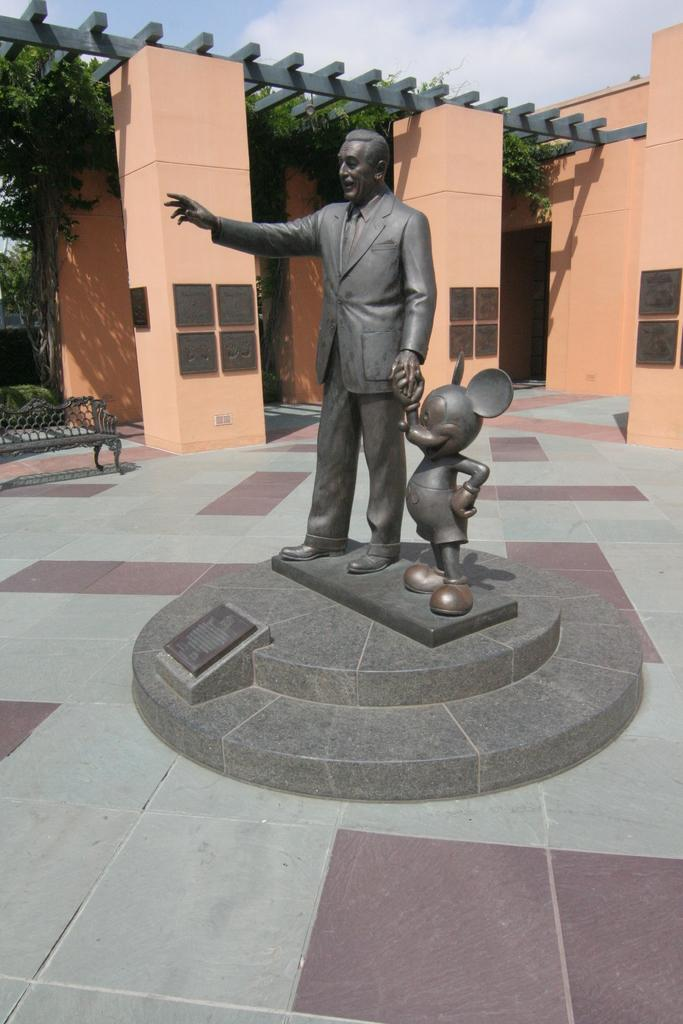What is the main subject in the image? There is a statue in the image. What can be seen in the background of the image? There are trees, a building, and the sky visible in the background of the image. What type of nerve can be seen in the image? There is no nerve present in the image; it features a statue and background elements. 